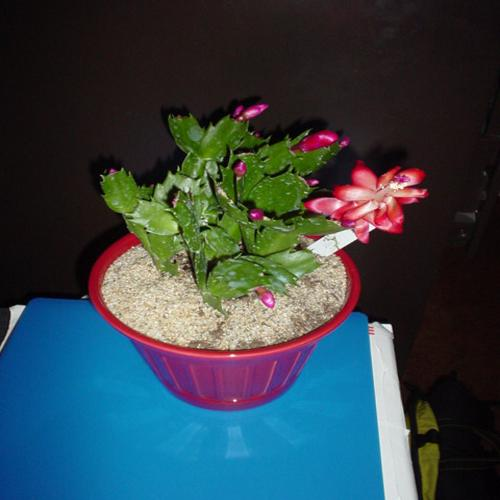How should I care for a plant like this? To care for a Christmas cactus, it's important to mimic its natural habitat. Ensure it has bright, indirect sunlight and maintain high humidity, possibly by placing a tray of water nearby. Water the cactus when the top inch of soil feels dry. During its growth period, you can feed it with a balanced houseplant fertilizer. To encourage blooming, provide 12-14 hours of darkness daily, starting around eight weeks before you want it to bloom. 